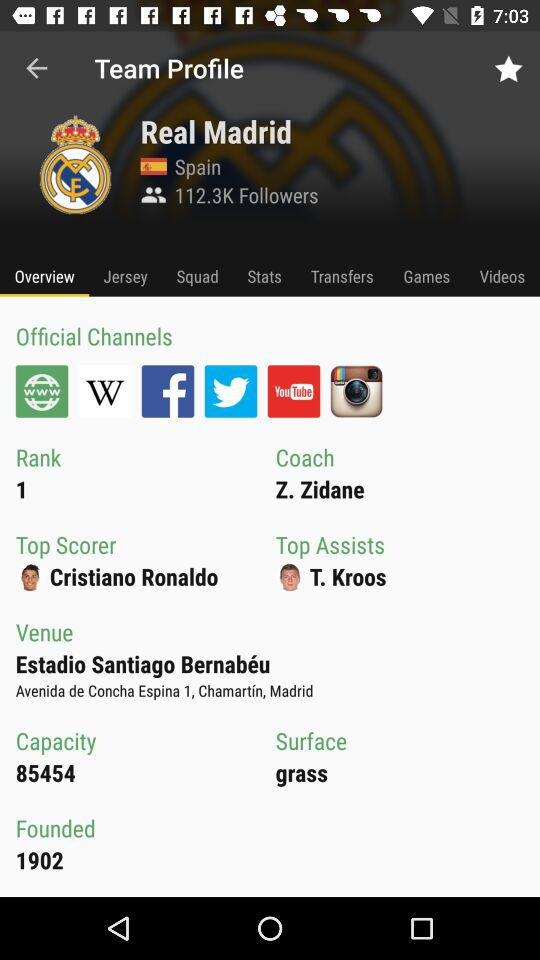To what country does "Real Madrid" belong? It belongs to Spain. 